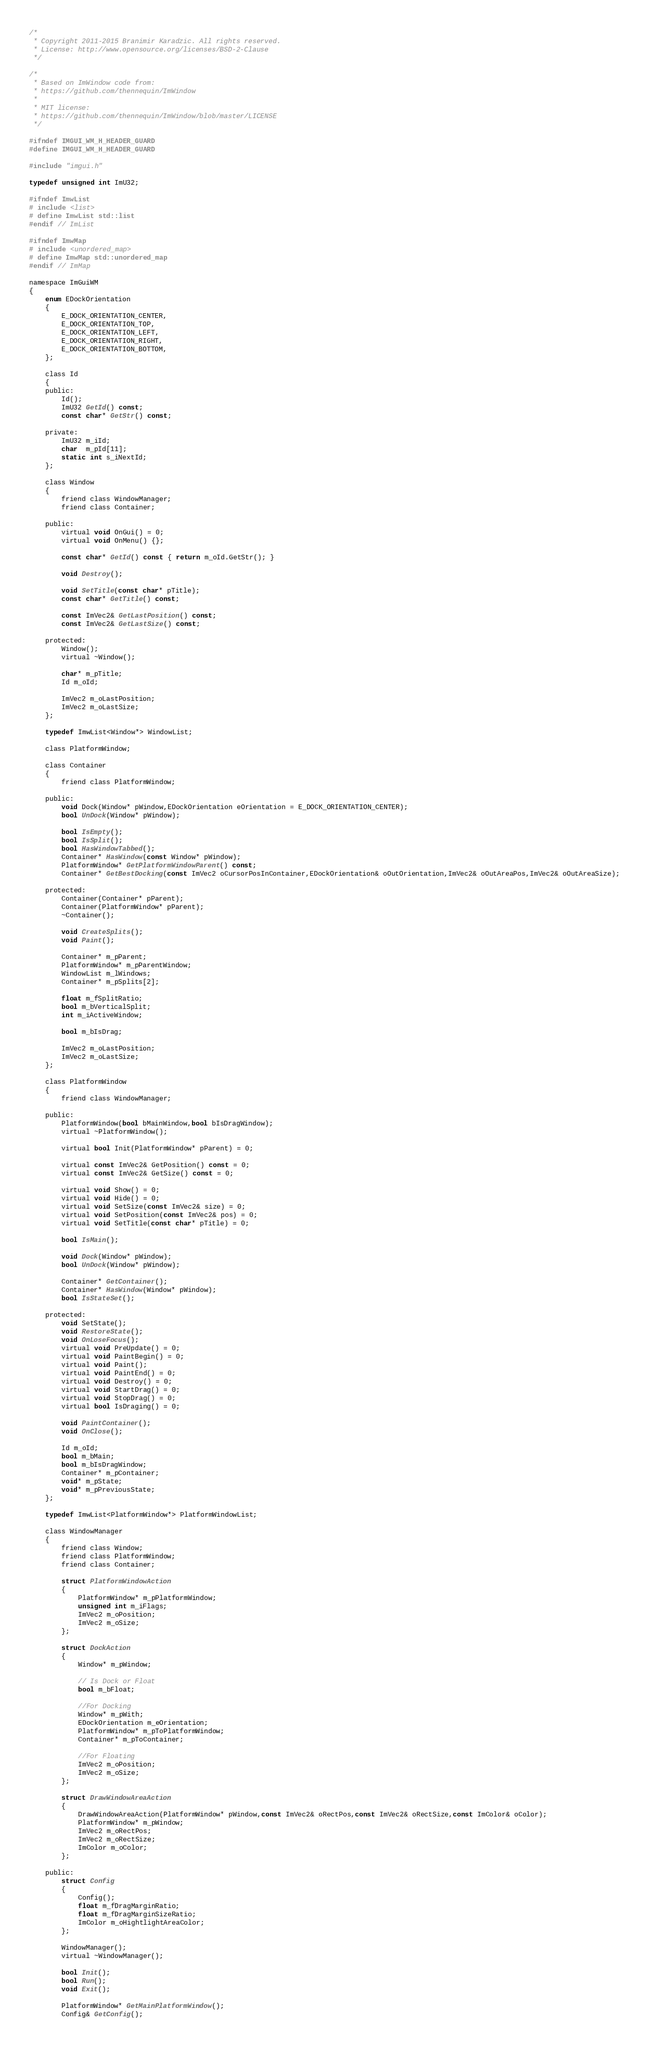<code> <loc_0><loc_0><loc_500><loc_500><_C_>/*
 * Copyright 2011-2015 Branimir Karadzic. All rights reserved.
 * License: http://www.opensource.org/licenses/BSD-2-Clause
 */

/*
 * Based on ImWindow code from:
 * https://github.com/thennequin/ImWindow
 *
 * MIT license:
 * https://github.com/thennequin/ImWindow/blob/master/LICENSE
 */

#ifndef IMGUI_WM_H_HEADER_GUARD
#define IMGUI_WM_H_HEADER_GUARD

#include "imgui.h"

typedef unsigned int ImU32;

#ifndef ImwList
# include <list>
# define ImwList std::list
#endif // ImList

#ifndef ImwMap
# include <unordered_map>
# define ImwMap std::unordered_map
#endif // ImMap

namespace ImGuiWM
{
    enum EDockOrientation
    {
        E_DOCK_ORIENTATION_CENTER,
        E_DOCK_ORIENTATION_TOP,
        E_DOCK_ORIENTATION_LEFT,
        E_DOCK_ORIENTATION_RIGHT,
        E_DOCK_ORIENTATION_BOTTOM,
    };

    class Id
    {
    public:
        Id();
        ImU32 GetId() const;
        const char* GetStr() const;

    private:
        ImU32 m_iId;
        char  m_pId[11];
        static int s_iNextId;
    };

    class Window
    {
        friend class WindowManager;
        friend class Container;

    public:
        virtual void OnGui() = 0;
        virtual void OnMenu() {};

        const char* GetId() const { return m_oId.GetStr(); }

        void Destroy();

        void SetTitle(const char* pTitle);
        const char* GetTitle() const;

        const ImVec2& GetLastPosition() const;
        const ImVec2& GetLastSize() const;

    protected:
        Window();
        virtual ~Window();

        char* m_pTitle;
        Id m_oId;

        ImVec2 m_oLastPosition;
        ImVec2 m_oLastSize;
    };

    typedef ImwList<Window*> WindowList;

    class PlatformWindow;

    class Container
    {
        friend class PlatformWindow;

    public:
        void Dock(Window* pWindow,EDockOrientation eOrientation = E_DOCK_ORIENTATION_CENTER);
        bool UnDock(Window* pWindow);

        bool IsEmpty();
        bool IsSplit();
        bool HasWindowTabbed();
        Container* HasWindow(const Window* pWindow);
        PlatformWindow* GetPlatformWindowParent() const;
        Container* GetBestDocking(const ImVec2 oCursorPosInContainer,EDockOrientation& oOutOrientation,ImVec2& oOutAreaPos,ImVec2& oOutAreaSize);

    protected:
        Container(Container* pParent);
        Container(PlatformWindow* pParent);
        ~Container();

        void CreateSplits();
        void Paint();

        Container* m_pParent;
        PlatformWindow* m_pParentWindow;
        WindowList m_lWindows;
        Container* m_pSplits[2];

        float m_fSplitRatio;
        bool m_bVerticalSplit;
        int m_iActiveWindow;

        bool m_bIsDrag;

        ImVec2 m_oLastPosition;
        ImVec2 m_oLastSize;
    };

    class PlatformWindow
    {
        friend class WindowManager;

    public:
        PlatformWindow(bool bMainWindow,bool bIsDragWindow);
        virtual ~PlatformWindow();

        virtual bool Init(PlatformWindow* pParent) = 0;

        virtual const ImVec2& GetPosition() const = 0;
        virtual const ImVec2& GetSize() const = 0;

        virtual void Show() = 0;
        virtual void Hide() = 0;
        virtual void SetSize(const ImVec2& size) = 0;
        virtual void SetPosition(const ImVec2& pos) = 0;
        virtual void SetTitle(const char* pTitle) = 0;

        bool IsMain();

        void Dock(Window* pWindow);
        bool UnDock(Window* pWindow);

        Container* GetContainer();
        Container* HasWindow(Window* pWindow);
        bool IsStateSet();

    protected:
        void SetState();
        void RestoreState();
        void OnLoseFocus();
        virtual void PreUpdate() = 0;
        virtual void PaintBegin() = 0;
        virtual void Paint();
        virtual void PaintEnd() = 0;
        virtual void Destroy() = 0;
        virtual void StartDrag() = 0;
        virtual void StopDrag() = 0;
        virtual bool IsDraging() = 0;

        void PaintContainer();
        void OnClose();

        Id m_oId;
        bool m_bMain;
        bool m_bIsDragWindow;
        Container* m_pContainer;
        void* m_pState;
        void* m_pPreviousState;
    };

    typedef ImwList<PlatformWindow*> PlatformWindowList;

    class WindowManager
    {
        friend class Window;
        friend class PlatformWindow;
        friend class Container;

        struct PlatformWindowAction
        {
            PlatformWindow* m_pPlatformWindow;
            unsigned int m_iFlags;
            ImVec2 m_oPosition;
            ImVec2 m_oSize;
        };

        struct DockAction
        {
            Window* m_pWindow;

            // Is Dock or Float
            bool m_bFloat;

            //For Docking
            Window* m_pWith;
            EDockOrientation m_eOrientation;
            PlatformWindow* m_pToPlatformWindow;
            Container* m_pToContainer;

            //For Floating
            ImVec2 m_oPosition;
            ImVec2 m_oSize;
        };

        struct DrawWindowAreaAction
        {
            DrawWindowAreaAction(PlatformWindow* pWindow,const ImVec2& oRectPos,const ImVec2& oRectSize,const ImColor& oColor);
            PlatformWindow* m_pWindow;
            ImVec2 m_oRectPos;
            ImVec2 m_oRectSize;
            ImColor m_oColor;
        };

    public:
        struct Config
        {
            Config();
            float m_fDragMarginRatio;
            float m_fDragMarginSizeRatio;
            ImColor m_oHightlightAreaColor;
        };

        WindowManager();
        virtual ~WindowManager();

        bool Init();
        bool Run();
        void Exit();

        PlatformWindow* GetMainPlatformWindow();
        Config& GetConfig();
</code> 